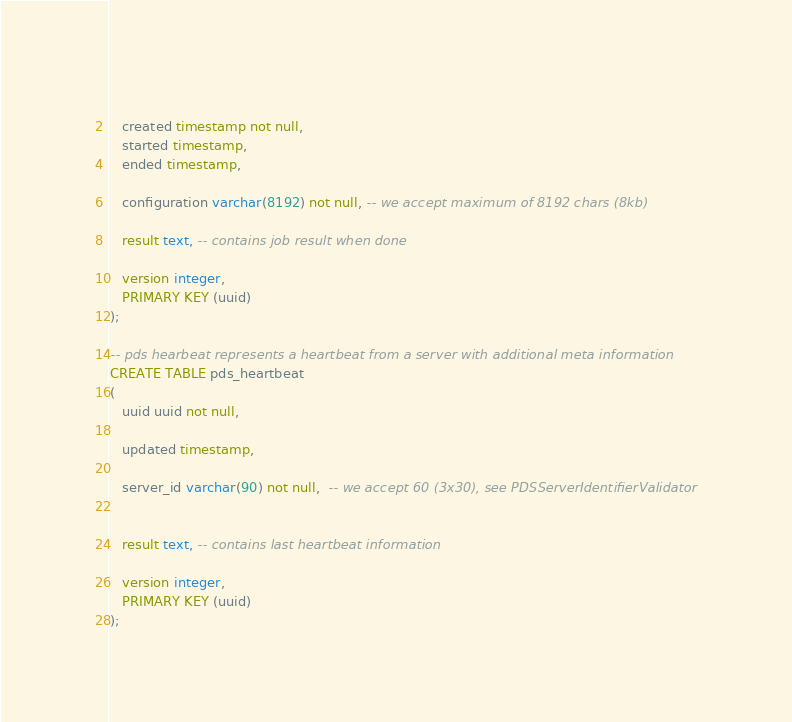<code> <loc_0><loc_0><loc_500><loc_500><_SQL_>   
   created timestamp not null,
   started timestamp,
   ended timestamp,
   
   configuration varchar(8192) not null, -- we accept maximum of 8192 chars (8kb)
   
   result text, -- contains job result when done
   
   version integer,
   PRIMARY KEY (uuid)
);

-- pds hearbeat represents a heartbeat from a server with additional meta information
CREATE TABLE pds_heartbeat
(
   uuid uuid not null,
   
   updated timestamp,
   
   server_id varchar(90) not null,  -- we accept 60 (3x30), see PDSServerIdentifierValidator
   
   
   result text, -- contains last heartbeat information
   
   version integer,
   PRIMARY KEY (uuid)
);
</code> 